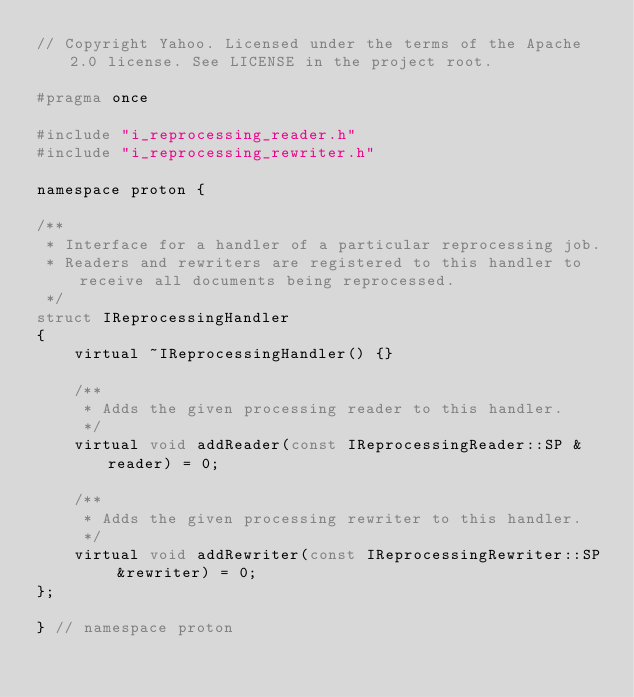<code> <loc_0><loc_0><loc_500><loc_500><_C_>// Copyright Yahoo. Licensed under the terms of the Apache 2.0 license. See LICENSE in the project root.

#pragma once

#include "i_reprocessing_reader.h"
#include "i_reprocessing_rewriter.h"

namespace proton {

/**
 * Interface for a handler of a particular reprocessing job.
 * Readers and rewriters are registered to this handler to receive all documents being reprocessed.
 */
struct IReprocessingHandler
{
    virtual ~IReprocessingHandler() {}

    /**
     * Adds the given processing reader to this handler.
     */
    virtual void addReader(const IReprocessingReader::SP &reader) = 0;

    /**
     * Adds the given processing rewriter to this handler.
     */
    virtual void addRewriter(const IReprocessingRewriter::SP &rewriter) = 0;
};

} // namespace proton

</code> 